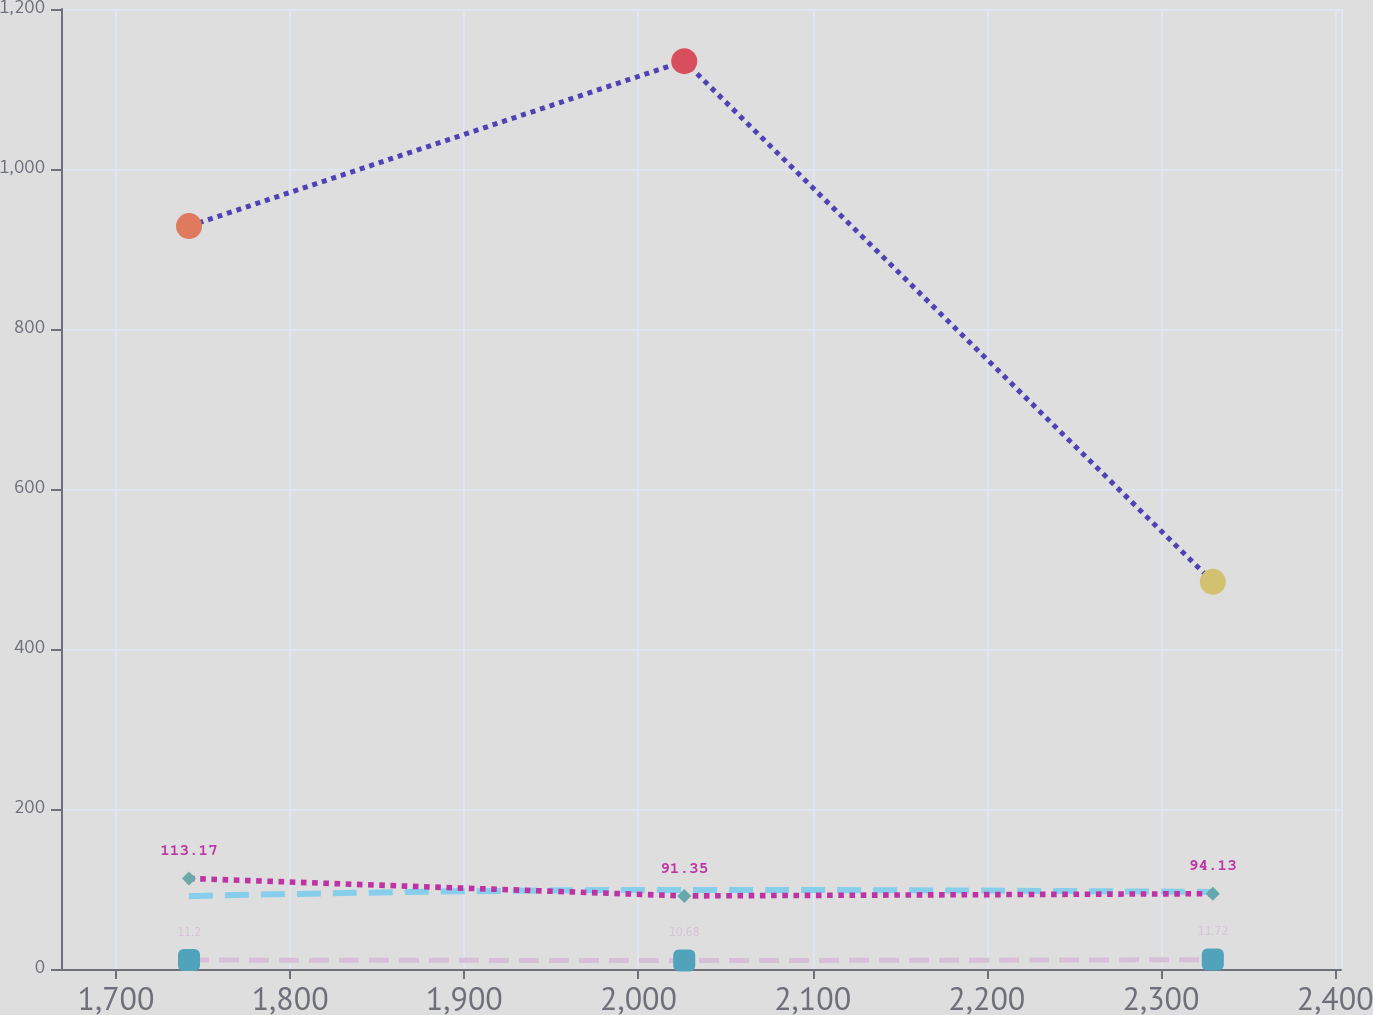Convert chart to OTSL. <chart><loc_0><loc_0><loc_500><loc_500><line_chart><ecel><fcel>Medicare   Part D subsidy<fcel>OPEB before  Medicare Part D subsidy<fcel>U.S.  defined benefit  pension plans<fcel>Non-U.S.  defined benefit  pension plans<nl><fcel>1741.93<fcel>928.65<fcel>91.02<fcel>113.17<fcel>11.2<nl><fcel>2026.27<fcel>1134.8<fcel>98.88<fcel>91.35<fcel>10.68<nl><fcel>2329.75<fcel>483.93<fcel>96.26<fcel>94.13<fcel>11.72<nl><fcel>2409.45<fcel>549.02<fcel>117.21<fcel>88.15<fcel>12.24<nl><fcel>2476.84<fcel>645.85<fcel>93.64<fcel>85.37<fcel>15.84<nl></chart> 